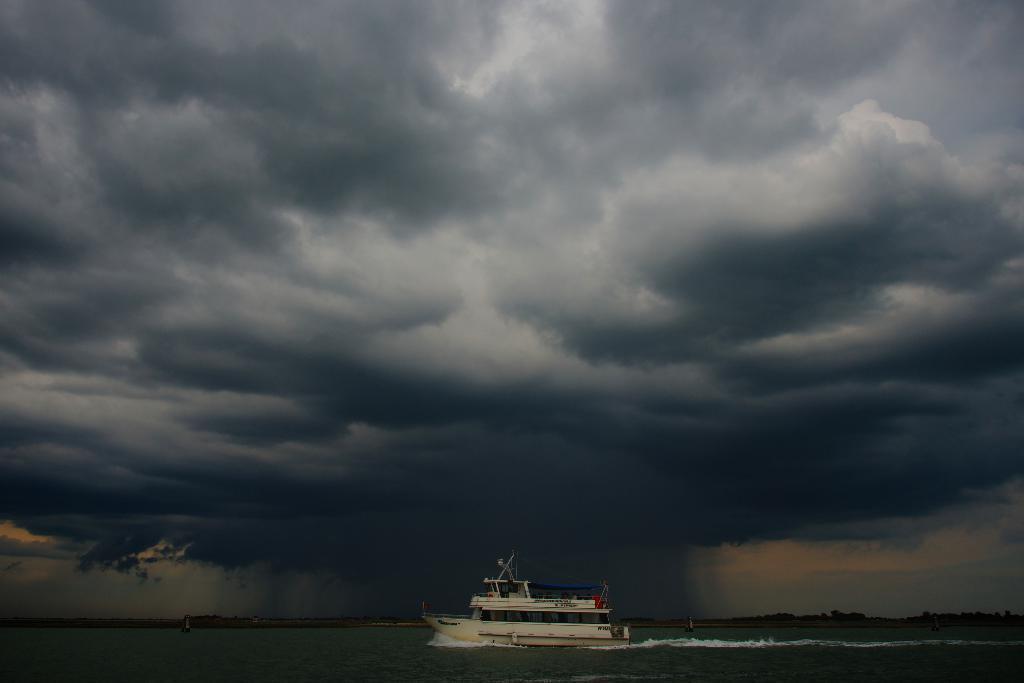In one or two sentences, can you explain what this image depicts? In this picture there is a white color boat in the water. On the top there is a sky and clouds. 